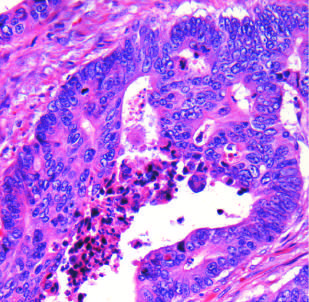s necrotic debris, present in the gland lumen, typical?
Answer the question using a single word or phrase. Yes 